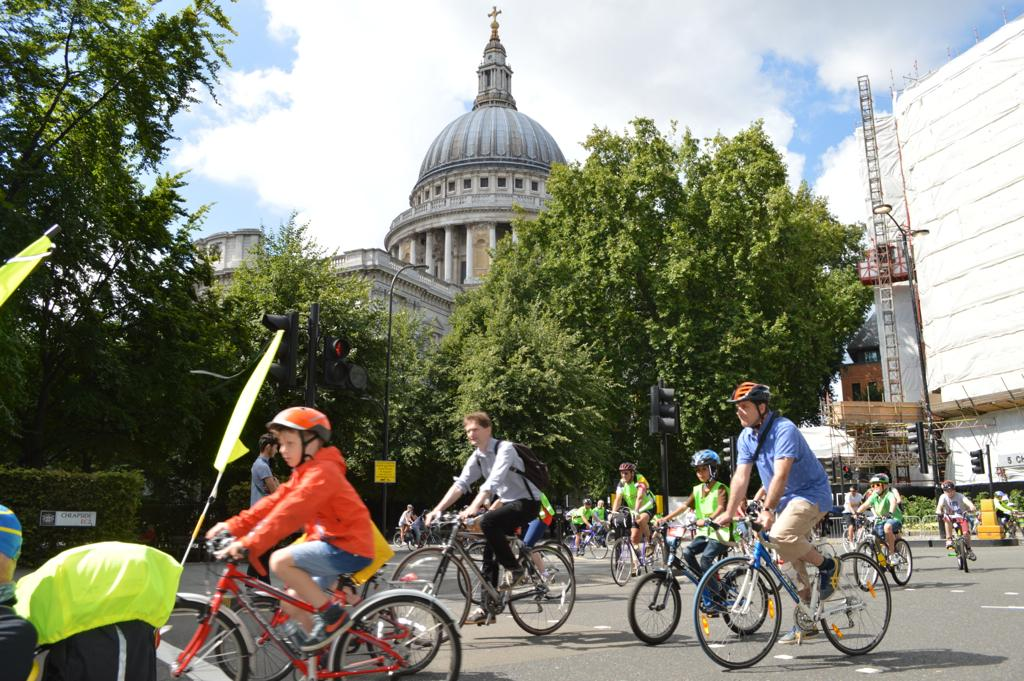How many people are in the image? There is a group of people in the image. What are the people doing in the image? The people are riding bicycles in the image. What can be seen in the background of the image? There are flags, plants, trees, a traffic signal, a pole, a light, and a building visible in the image. What is the condition of the sky in the image? The sky is visible in the image and is covered with clouds. What class are the people attending in the image? There is no indication of a class in the image. --- Facts: 1. There is a group of people in the image. 12. The people are wearing costumes. 13. There is a stage in the image. 14. There are balloons in the image. 15. There is a banner in the image. 16. There is a microphone in the image. 17. There is a spotlight in the image. 18. There is a DJ booth in the image. 19. There is a dance floor in the image. 120. There is a disco ball in the image. 121. There is a fog machine in the image. 122. There is a confetti cannon in the image. 123. There is a punch bowl in the image. 124. There is a cake in the image. 125. There is a birthday candle in the image. 126. There is a present box in the image. 127. There is a camera in the image. 128. There is a clock in the image. 129. There is a gift card in the image. 130. There is a party hat in the image. 131. There is a party horn in the image. 132. There is a party popper in the image. 133. There is a party streamer in the image. 134. There is a party balloon arch in the image. 135. There is a party table in the image. 136. There is a party chair in the image. 137. There is a party decoration in the image. 138. There is a party food in the image. 139. There is a party drink in the image. 140. There is a party music in the image. 141. There is a party guest in the image. 142. There is a party host in the image. 143. There is a party photographer in the image. 144. There is a party guest list in the image. 145. There is a party invitation in the image. 146. There is a party thank you card in the image. 147. There is a party favor 